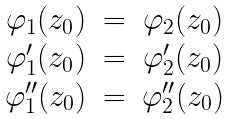<formula> <loc_0><loc_0><loc_500><loc_500>\begin{matrix} \varphi _ { 1 } ( z _ { 0 } ) & = & \varphi _ { 2 } ( z _ { 0 } ) \\ \varphi _ { 1 } ^ { \prime } ( z _ { 0 } ) & = & \varphi _ { 2 } ^ { \prime } ( z _ { 0 } ) \\ \varphi _ { 1 } ^ { \prime \prime } ( z _ { 0 } ) & = & \varphi _ { 2 } ^ { \prime \prime } ( z _ { 0 } ) \end{matrix}</formula> 